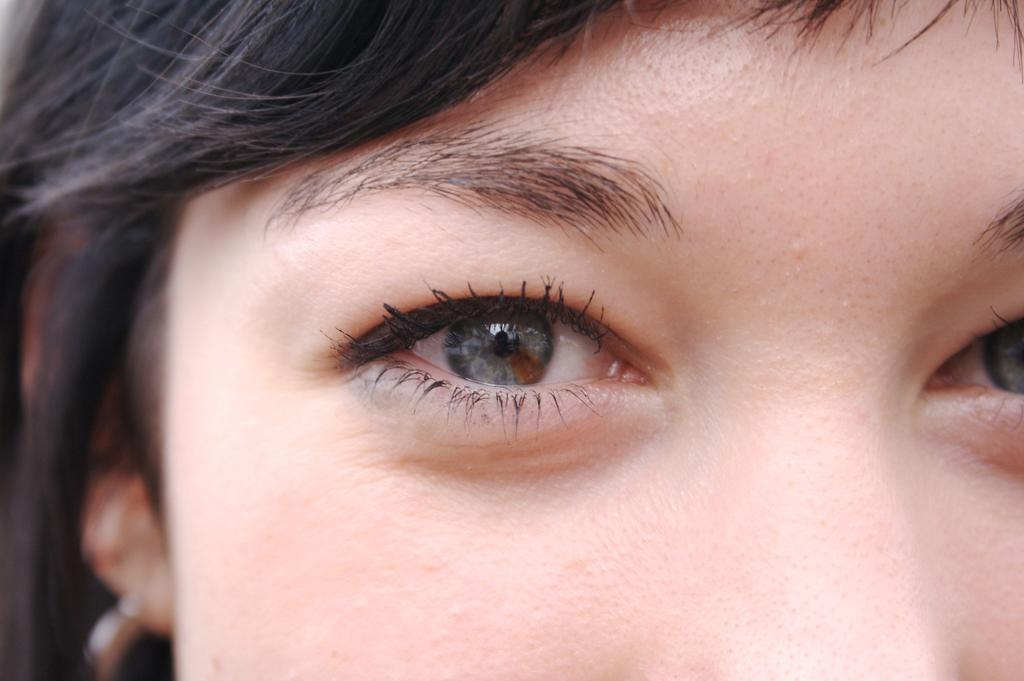What is the main subject of the image? There is a lady in the image. What type of government is depicted in the image? There is no reference to any government or political system in the image; it features a lady. 